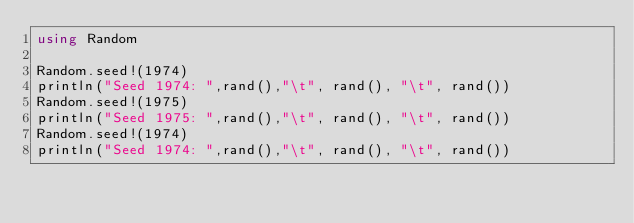<code> <loc_0><loc_0><loc_500><loc_500><_Julia_>using Random

Random.seed!(1974)
println("Seed 1974: ",rand(),"\t", rand(), "\t", rand())
Random.seed!(1975)
println("Seed 1975: ",rand(),"\t", rand(), "\t", rand())
Random.seed!(1974)
println("Seed 1974: ",rand(),"\t", rand(), "\t", rand())
</code> 